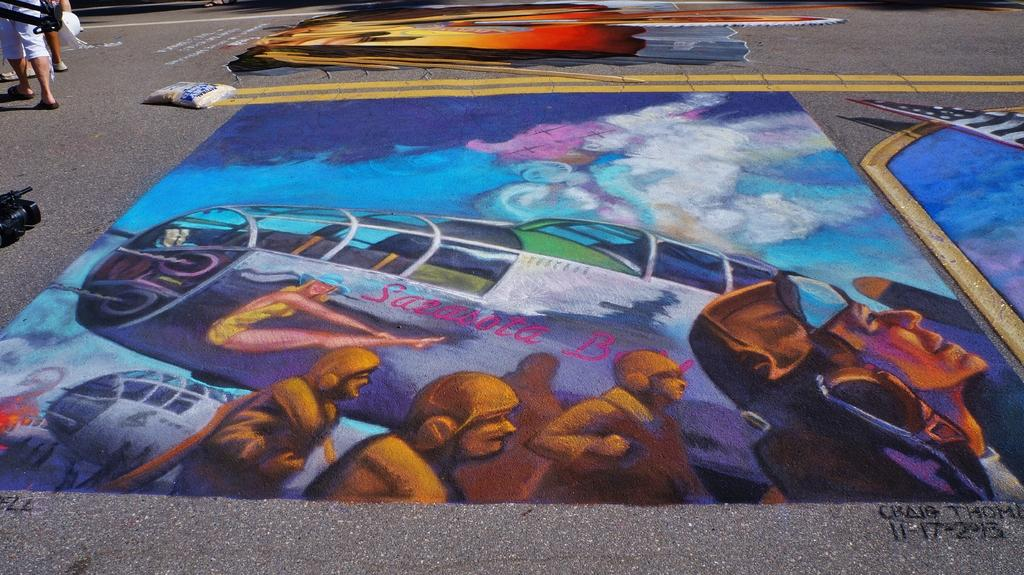What is the main subject of the image? There is a piece of art in the image. Where is the piece of art located? The piece of art is on the road. What type of trouble is the stocking causing on the curve in the image? There is no stocking or curve present in the image; it only features a piece of art on the road. 